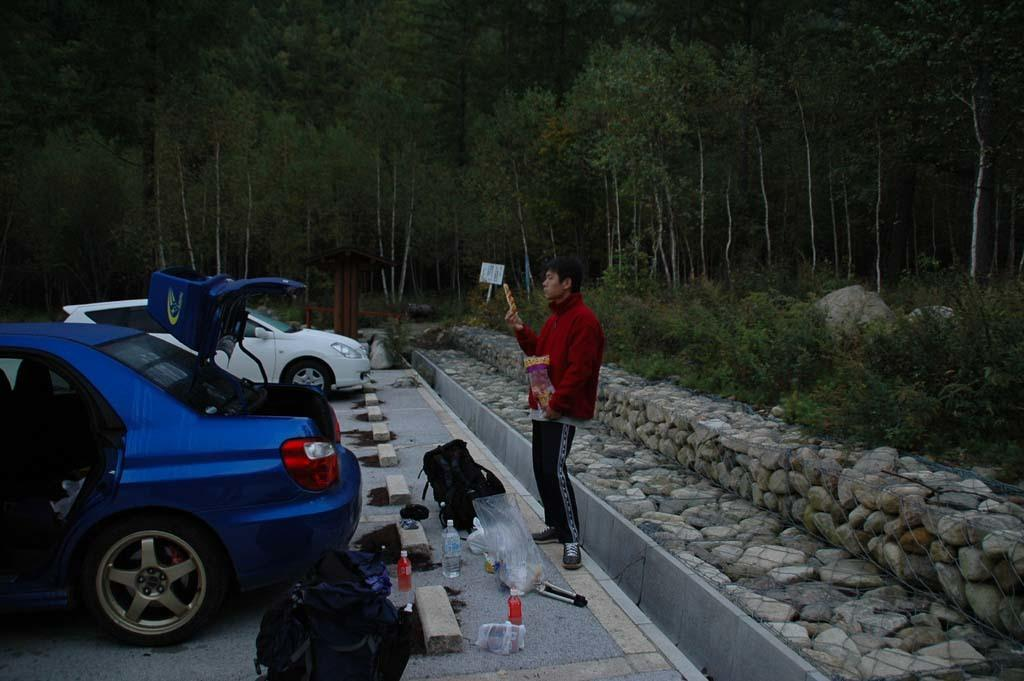What type of vehicles can be seen in the image? There are cars in the image. What objects are present in addition to the cars? There are bags, bottles, rocks, and a person wearing a red jacket in the image. Are there any natural elements visible in the image? Yes, there are trees in the image. Reasoning: Let's think step by identifying the main subjects and objects in the image based on the provided facts. We then formulate questions that focus on the location and characteristics of these subjects and objects, ensuring that each question can be answered definitively with the information given. We avoid yes/no questions and ensure that the language is simple and clear. Absurd Question/Answer: What type of yam is being prepared by the person wearing a red jacket in the image? There is no yam present in the image, and the person wearing a red jacket is not shown preparing any food. What type of trousers is the person wearing a red jacket in the image? The provided facts do not mention the type of trousers the person is wearing; only the red jacket is mentioned. What time of day is it in the image, as indicated by the hour on a clock? There is no clock visible in the image, and therefore no indication of the time of day. 